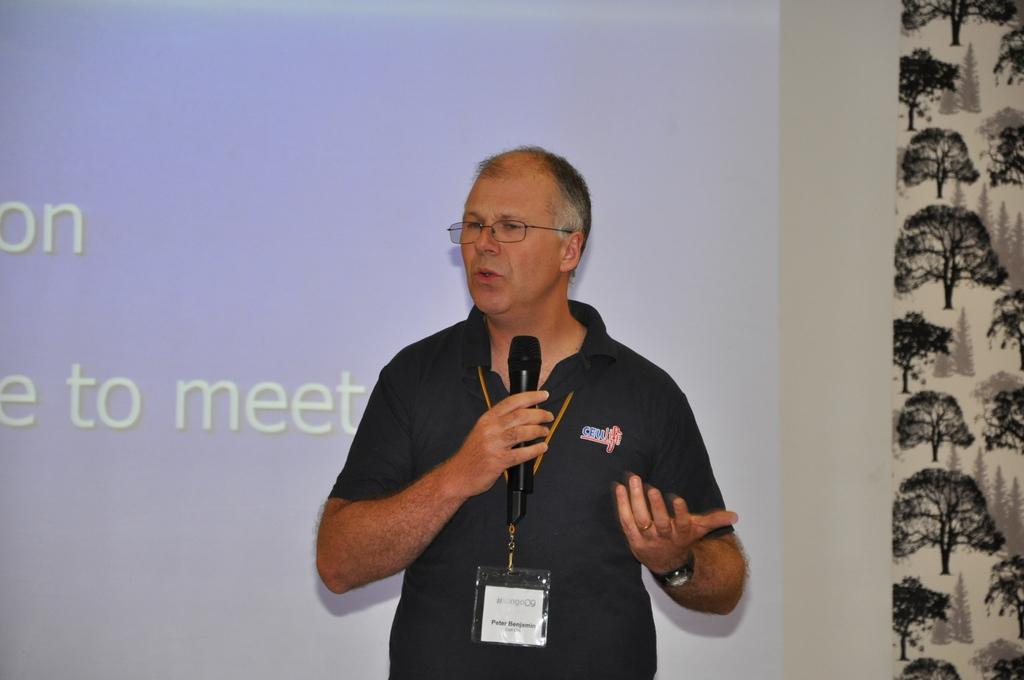What is the main subject of the image? There is a man in the image. What is the man doing in the image? The man is standing in the image. What object is the man holding in his hand? The man is holding a microphone in his hand. What can be seen on the man's clothing? The man is wearing an ID card. What accessory is the man wearing on his face? The man is wearing spectacles. What can be seen on the wall in the image? There is a projector light on the wall in the image. What type of clover is the man holding in his hand instead of a microphone? There is no clover present in the image; the man is holding a microphone. How many pickles can be seen on the wall next to the projector light? There are no pickles present in the image; only the projector light can be seen on the wall. 